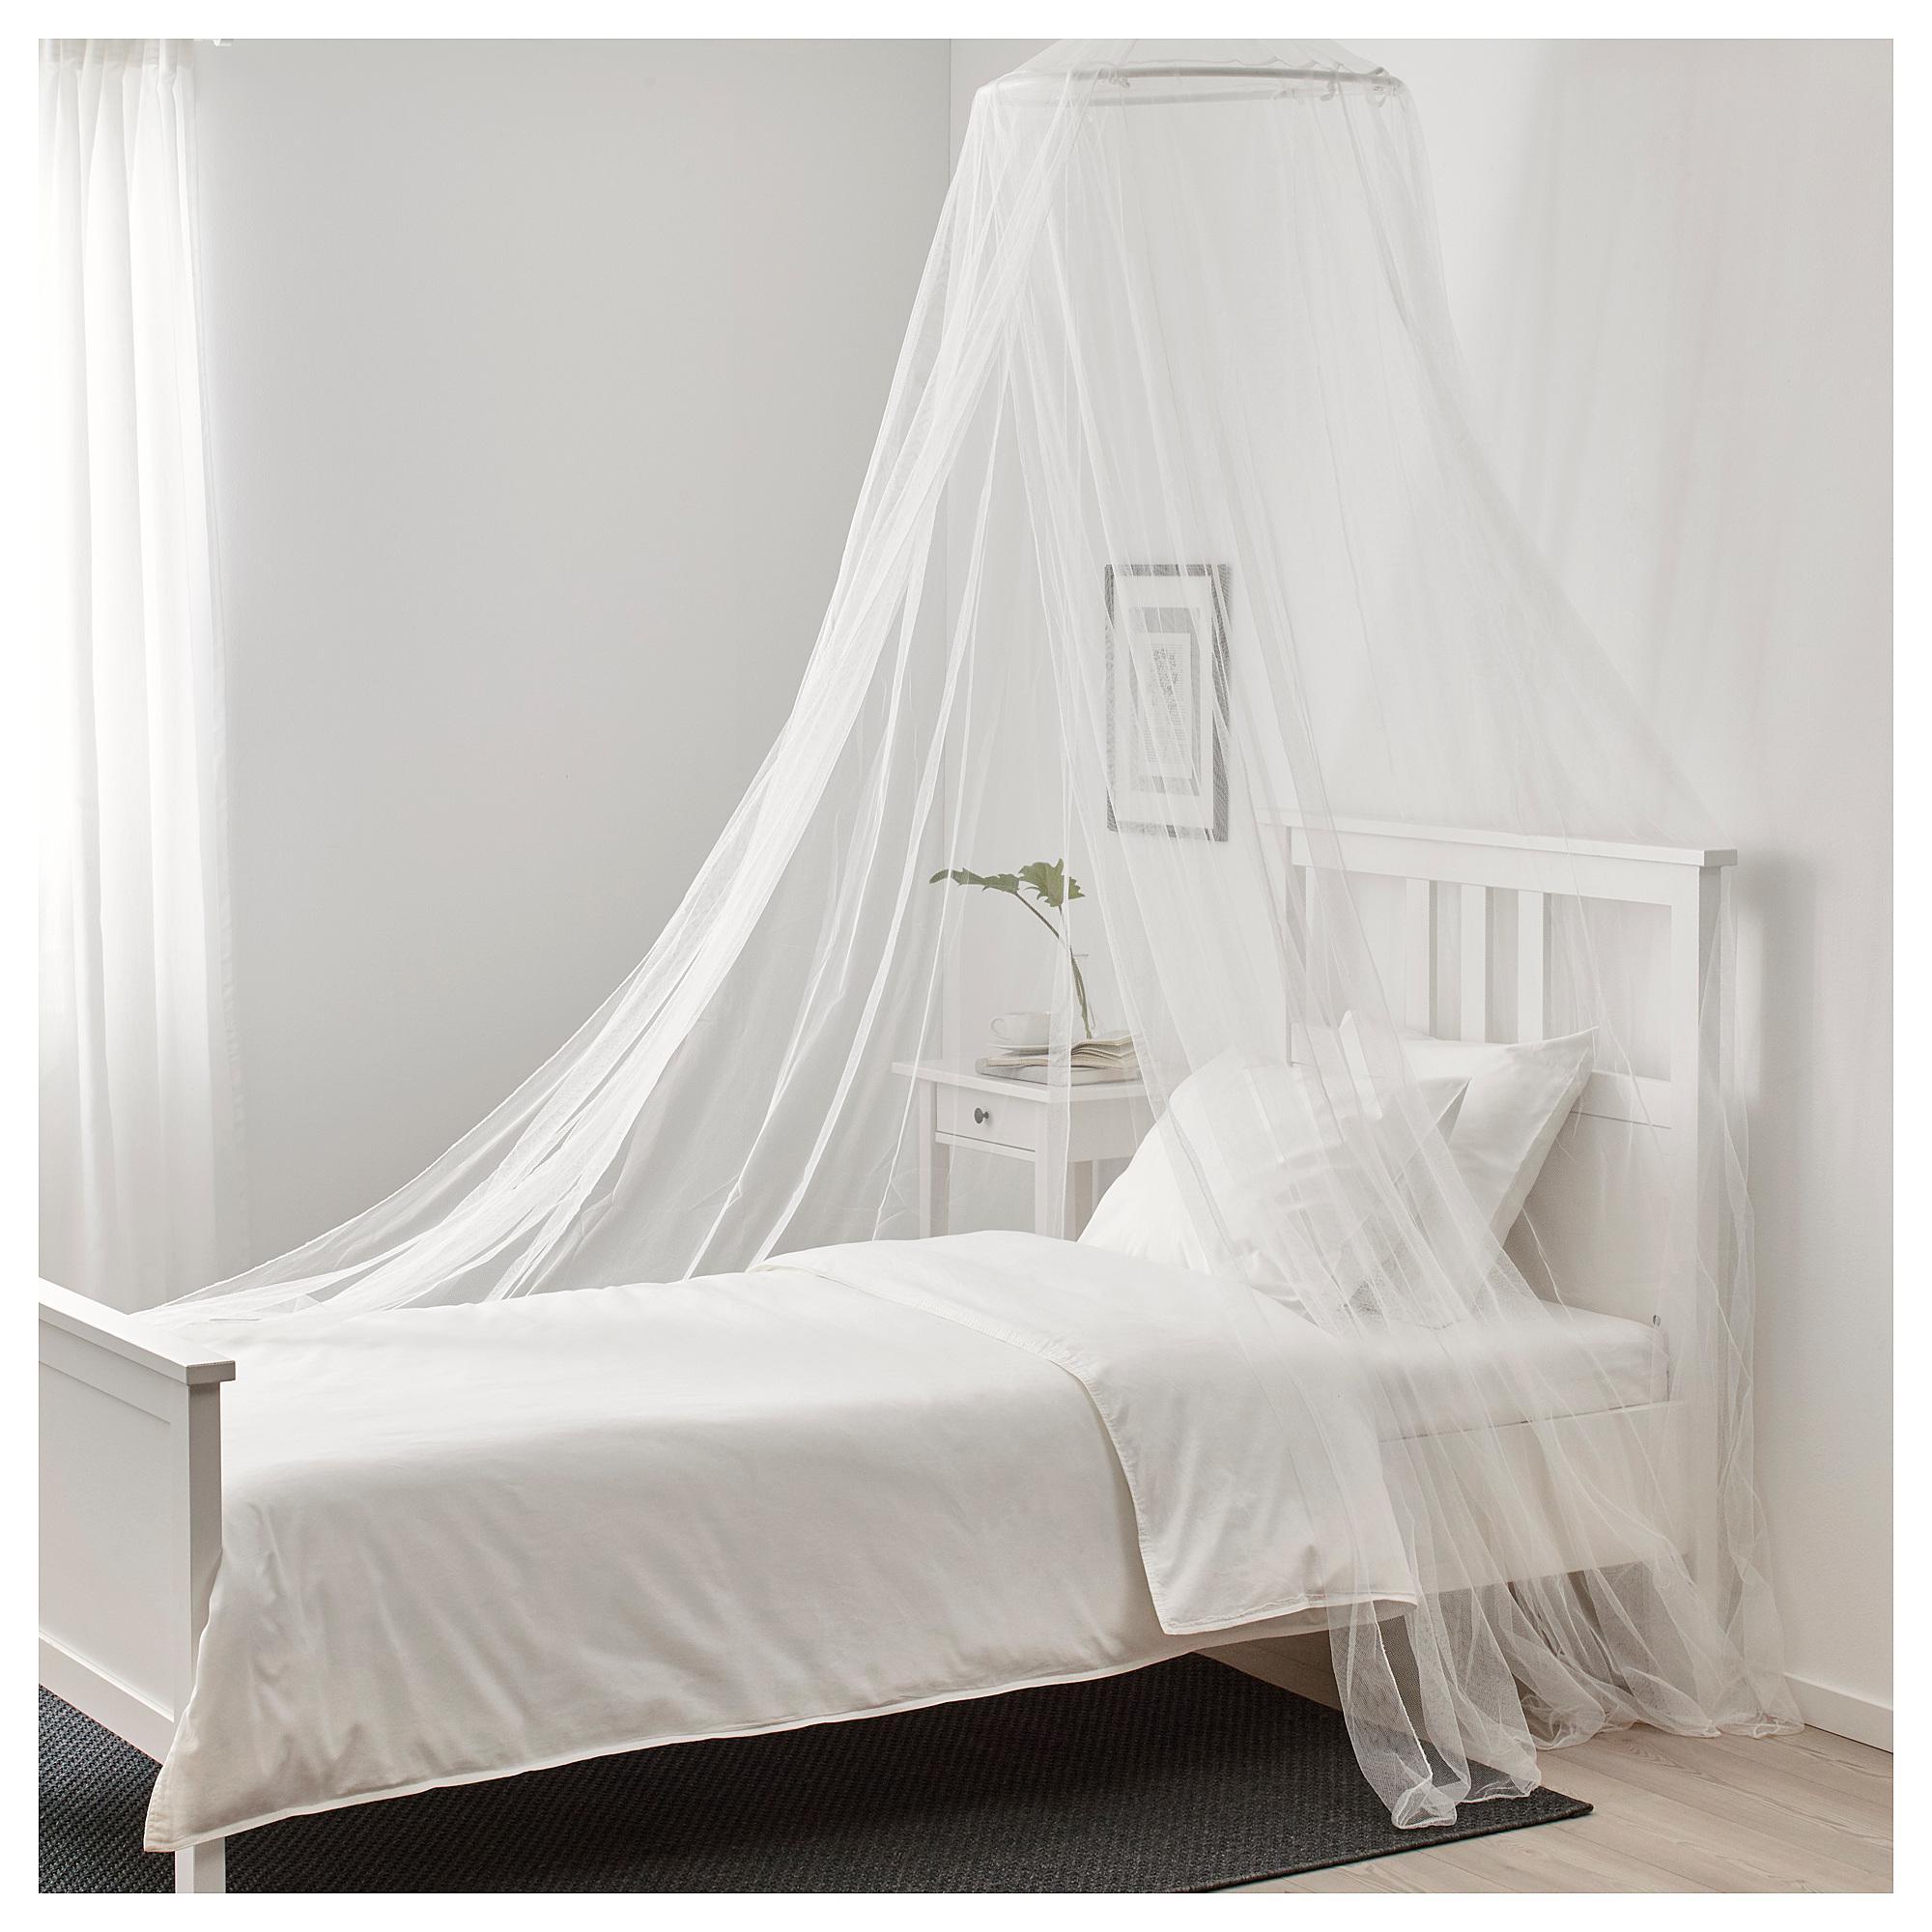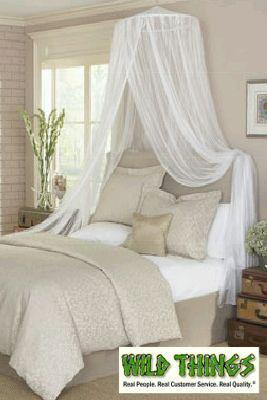The first image is the image on the left, the second image is the image on the right. For the images shown, is this caption "The right image shows at least one bed canopy, but no bed is shown." true? Answer yes or no. No. The first image is the image on the left, the second image is the image on the right. For the images displayed, is the sentence "There are two bed with two white canopies." factually correct? Answer yes or no. Yes. 